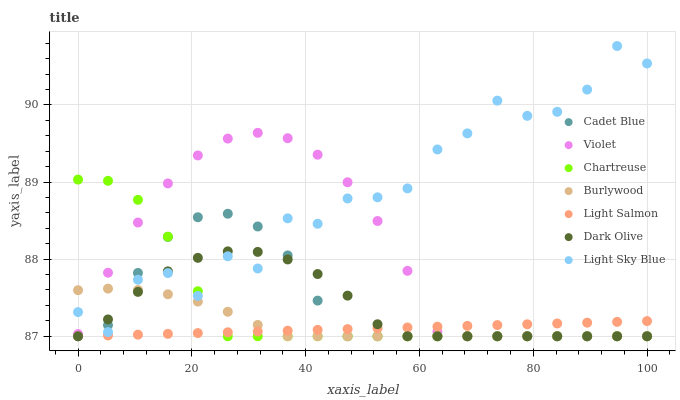Does Light Salmon have the minimum area under the curve?
Answer yes or no. Yes. Does Light Sky Blue have the maximum area under the curve?
Answer yes or no. Yes. Does Cadet Blue have the minimum area under the curve?
Answer yes or no. No. Does Cadet Blue have the maximum area under the curve?
Answer yes or no. No. Is Light Salmon the smoothest?
Answer yes or no. Yes. Is Light Sky Blue the roughest?
Answer yes or no. Yes. Is Cadet Blue the smoothest?
Answer yes or no. No. Is Cadet Blue the roughest?
Answer yes or no. No. Does Light Salmon have the lowest value?
Answer yes or no. Yes. Does Light Sky Blue have the lowest value?
Answer yes or no. No. Does Light Sky Blue have the highest value?
Answer yes or no. Yes. Does Cadet Blue have the highest value?
Answer yes or no. No. Is Light Salmon less than Light Sky Blue?
Answer yes or no. Yes. Is Light Sky Blue greater than Light Salmon?
Answer yes or no. Yes. Does Light Sky Blue intersect Dark Olive?
Answer yes or no. Yes. Is Light Sky Blue less than Dark Olive?
Answer yes or no. No. Is Light Sky Blue greater than Dark Olive?
Answer yes or no. No. Does Light Salmon intersect Light Sky Blue?
Answer yes or no. No. 